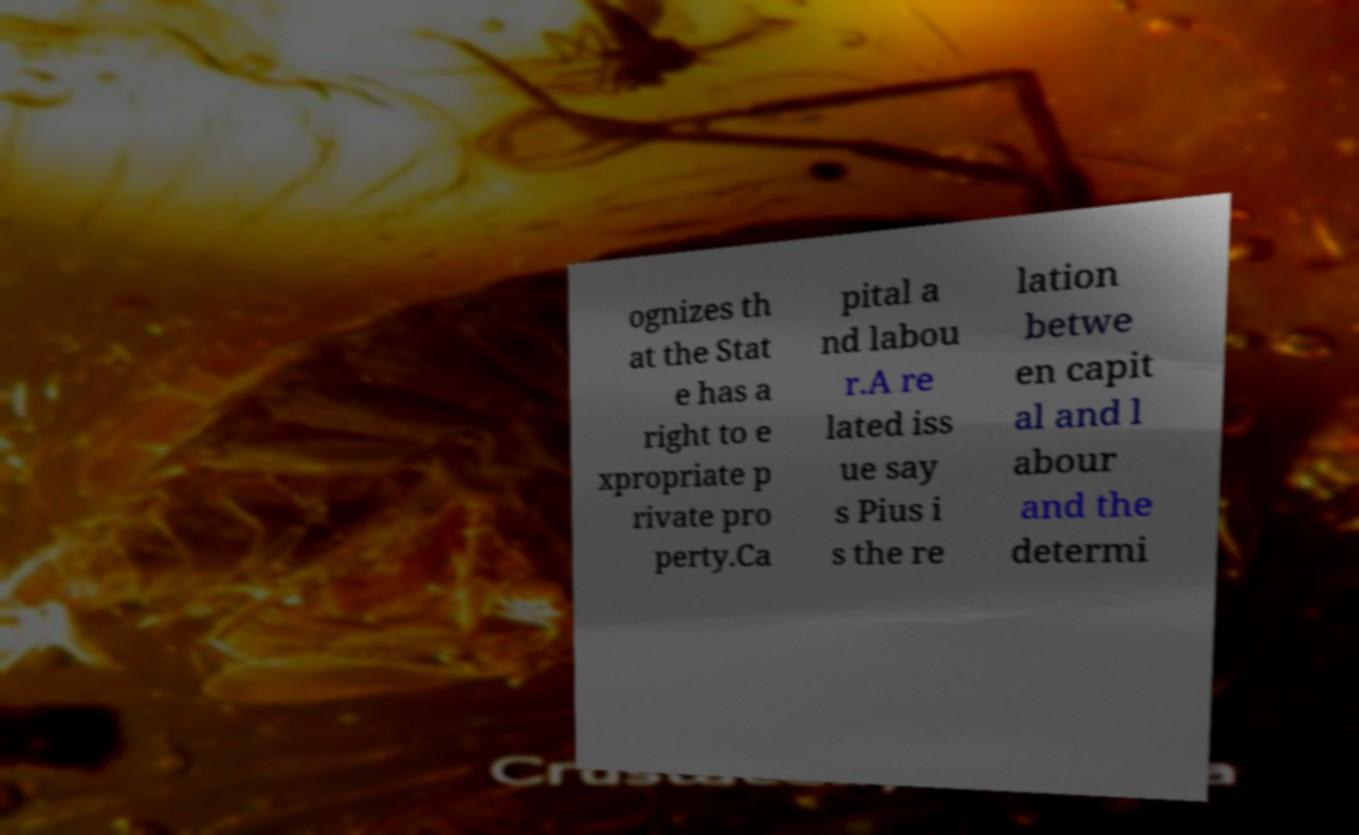There's text embedded in this image that I need extracted. Can you transcribe it verbatim? ognizes th at the Stat e has a right to e xpropriate p rivate pro perty.Ca pital a nd labou r.A re lated iss ue say s Pius i s the re lation betwe en capit al and l abour and the determi 